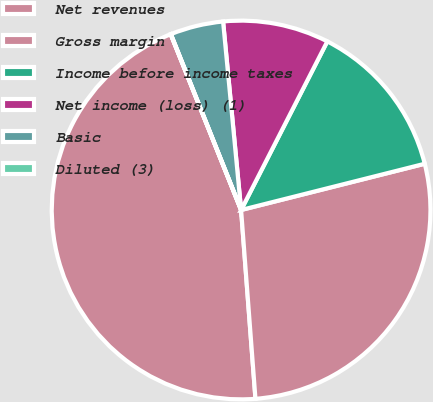Convert chart. <chart><loc_0><loc_0><loc_500><loc_500><pie_chart><fcel>Net revenues<fcel>Gross margin<fcel>Income before income taxes<fcel>Net income (loss) (1)<fcel>Basic<fcel>Diluted (3)<nl><fcel>45.14%<fcel>27.72%<fcel>13.55%<fcel>9.04%<fcel>4.53%<fcel>0.02%<nl></chart> 